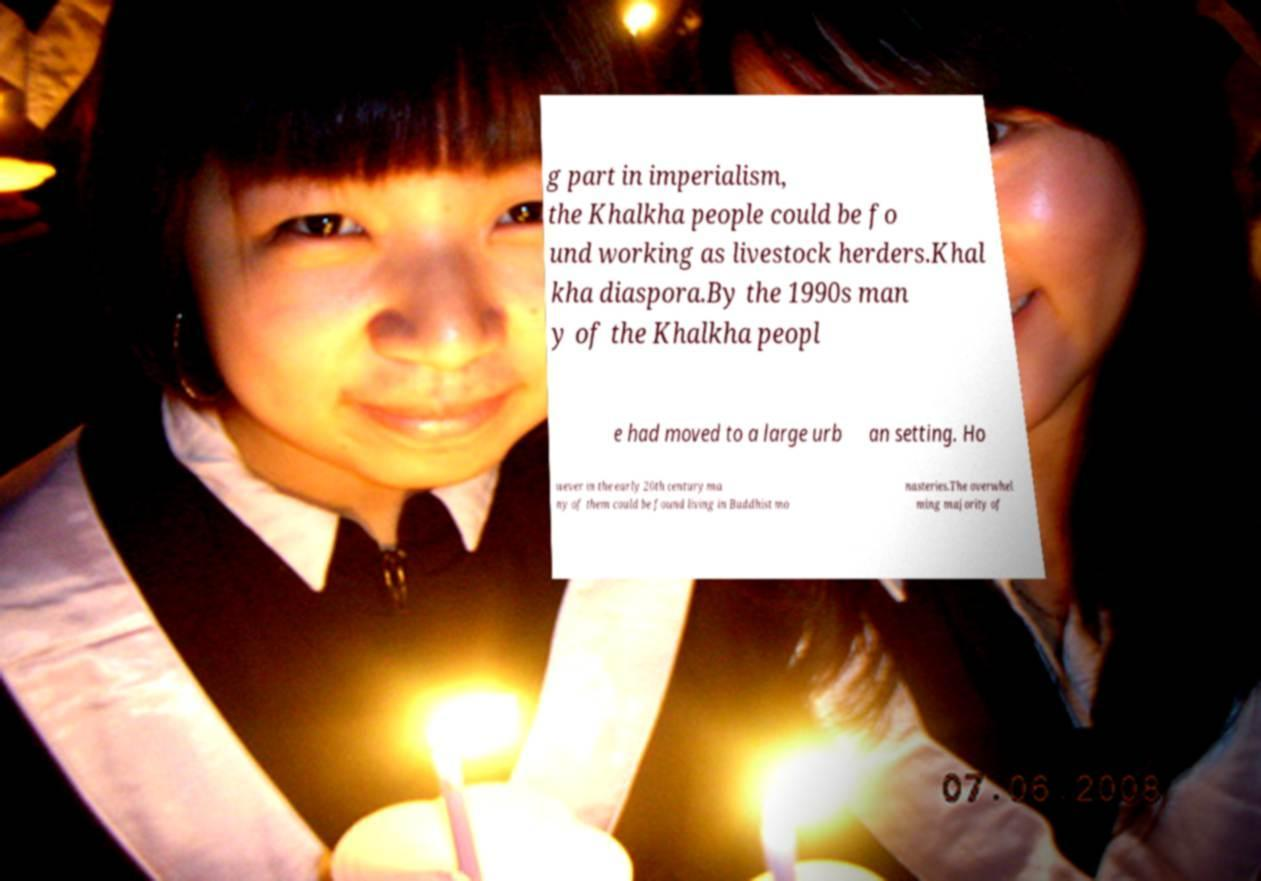Please identify and transcribe the text found in this image. g part in imperialism, the Khalkha people could be fo und working as livestock herders.Khal kha diaspora.By the 1990s man y of the Khalkha peopl e had moved to a large urb an setting. Ho wever in the early 20th century ma ny of them could be found living in Buddhist mo nasteries.The overwhel ming majority of 